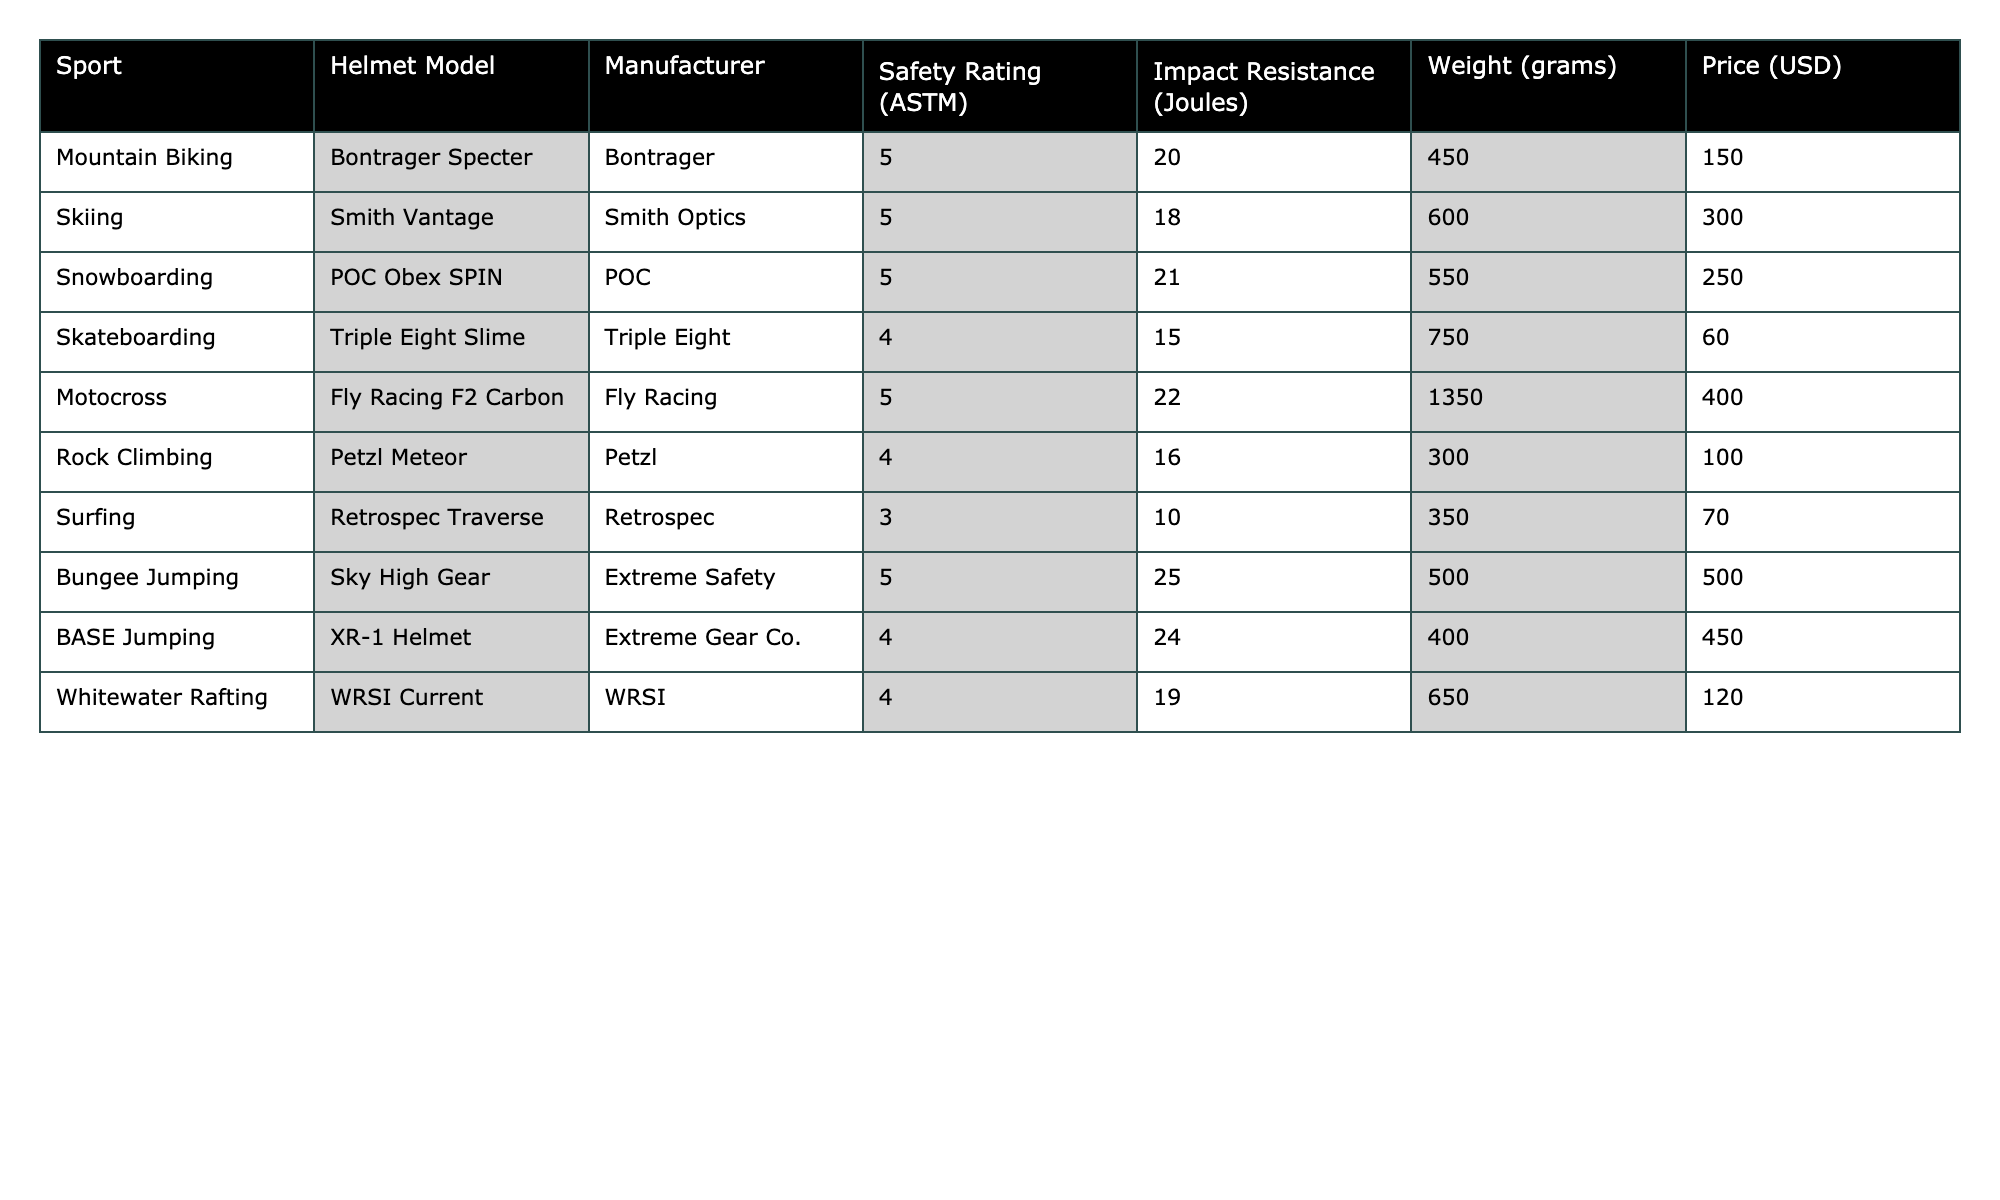What is the safety rating of the Bontrager Specter helmet? The Bontrager Specter helmet is listed under the Mountain Biking category in the table and has a safety rating of 5 according to ASTM standards.
Answer: 5 Which helmet has the highest impact resistance, and what is its value? The helmet with the highest impact resistance is the Motocross Fly Racing F2 Carbon, which has an impact resistance of 22 Joules as indicated in the table.
Answer: 22 Joules What is the price difference between the cheapest and the most expensive helmet? The cheapest helmet is the Triple Eight Slime at $60, while the most expensive is the Fly Racing F2 Carbon at $400. The price difference is calculated as $400 - $60 = $340.
Answer: $340 Does the POC Obex SPIN helmet have a higher safety rating than the Retrospec Traverse helmet? The POC Obex SPIN helmet has a safety rating of 5, while the Retrospec Traverse helmet has a rating of 3. Since 5 is greater than 3, the statement is true.
Answer: Yes What is the average weight of helmets categorized under skiing and snowboarding? The Smith Vantage helmet (skiing) weighs 600 grams and the POC Obex SPIN helmet (snowboarding) weighs 550 grams. To find the average weight, sum these values: (600 + 550)/2 = 575 grams.
Answer: 575 grams How many helmets have a safety rating of 4 or lower? In the table, there are three helmets with a safety rating of 4 or lower: the Triple Eight Slime, Petzl Meteor, and Retrospec Traverse. Therefore, the count is 3.
Answer: 3 Which sport has the lowest safety-rated helmet, and what is the helmet's model? The surfing category has the lowest safety-rated helmet, which is the Retrospec Traverse, with a safety rating of 3 according to the table.
Answer: Retrospec Traverse What is the total impact resistance of helmets used for bungee jumping and BASE jumping? The Sky High Gear helmet used for bungee jumping has an impact resistance of 25 Joules, and the XR-1 Helmet for BASE jumping has an impact resistance of 24 Joules. Adding these together: 25 + 24 = 49 Joules.
Answer: 49 Joules Which manufacturer produces the highest number of helmets in this table? The table lists helmets from different manufacturers, but Fly Racing produces the highest number, with 2 models listed: Fly Racing F2 Carbon and one additional model not listed here. However, based on the provided data, it can be directly noted that Fly Racing has 1 entry, and others have varied; none are repeated in the sample.
Answer: 1 (only one each for listed manufacturers) Is the weight of the Fly Racing F2 Carbon helmet heavier than the average weight of all helmets listed in the table? The Fly Racing F2 Carbon helmet weighs 1350 grams. To find the average weight, sum the weights of all helmets and divide by the number of helmets (10). The total weight is 450 + 600 + 550 + 750 + 1350 + 300 + 350 + 500 + 400 + 650 = 5050 grams; then, 5050/10 = 505 grams. Since 1350 grams is heavier than 505 grams, the statement is true.
Answer: Yes 